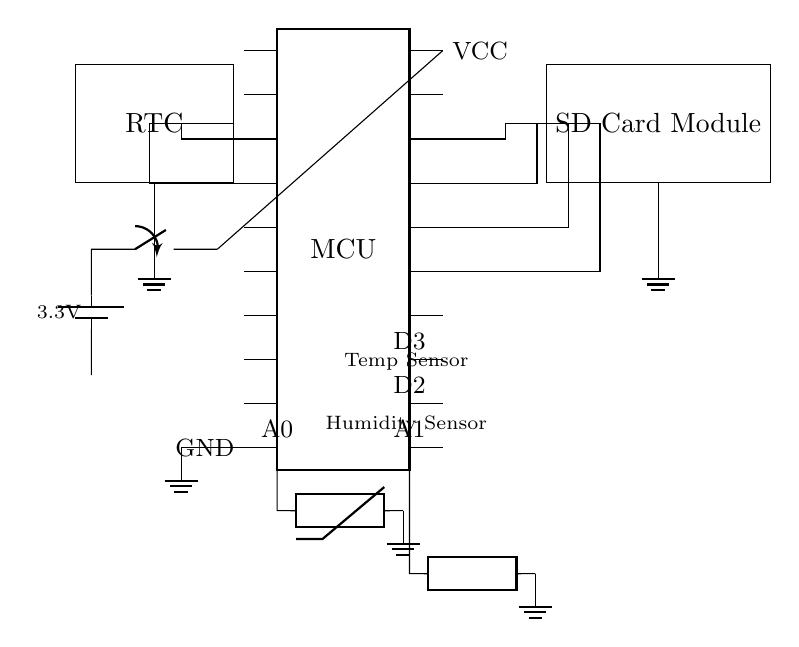what is the main microcontroller used in this circuit? The main microcontroller is labeled as 'MCU,' and it typically refers to a specific type of microcontroller which can perform various tasks for data logging in an embedded system.
Answer: MCU how many pins does the microcontroller have? The microcontroller is depicted as having 20 pins, which include both analog and digital inputs/outputs utilized in the circuit.
Answer: 20 which sensors are included in the circuit? There are two types of sensors shown: a thermistor for temperature measurement and a generic sensor for humidity measurement. Both sensor types are connected to the microcontroller's analog inputs.
Answer: Temperature Sensor, Humidity Sensor what is the purpose of the SD Card Module in this circuit? The SD Card Module is used for data storage, allowing the microcontroller to save logged environmental data from the sensors for later analysis or retrieval.
Answer: Data storage how is the circuit powered? The circuit is powered by a 3.3V battery, indicated by the battery symbol in the diagram, which is shown connected to the microcontroller's power input.
Answer: 3.3V Battery what role does the RTC play in this circuit? The Real-Time Clock (RTC) is responsible for keeping track of the current time and date, enabling the microcontroller to timestamp the logged data, which is essential for environmental monitoring.
Answer: Timestamping what is the function of the switch in this circuit? The switch allows the user to turn the circuit on or off, controlling the power to the microcontroller and other components, thus conserving energy when the device is not in use.
Answer: Power control 